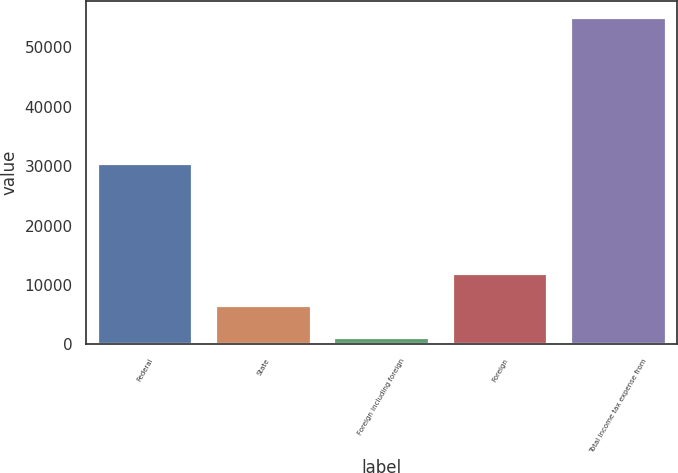Convert chart. <chart><loc_0><loc_0><loc_500><loc_500><bar_chart><fcel>Federal<fcel>State<fcel>Foreign including foreign<fcel>Foreign<fcel>Total income tax expense from<nl><fcel>30325<fcel>6534.5<fcel>1146<fcel>11923<fcel>55031<nl></chart> 